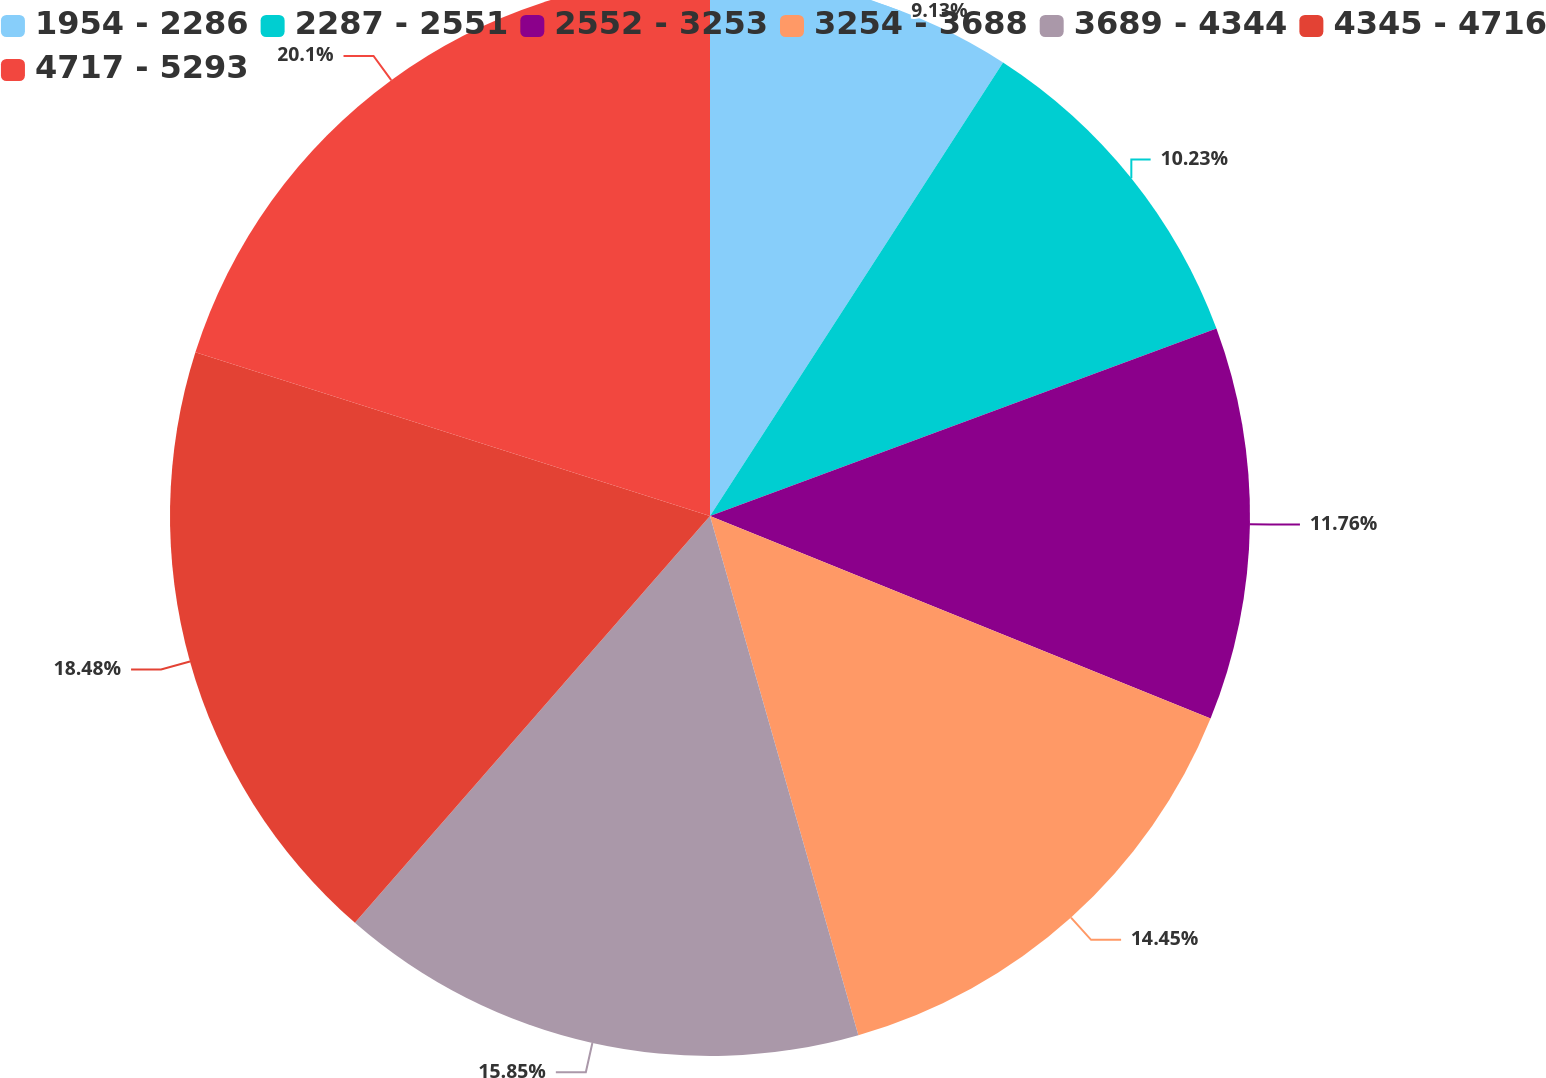Convert chart to OTSL. <chart><loc_0><loc_0><loc_500><loc_500><pie_chart><fcel>1954 - 2286<fcel>2287 - 2551<fcel>2552 - 3253<fcel>3254 - 3688<fcel>3689 - 4344<fcel>4345 - 4716<fcel>4717 - 5293<nl><fcel>9.13%<fcel>10.23%<fcel>11.76%<fcel>14.45%<fcel>15.85%<fcel>18.48%<fcel>20.1%<nl></chart> 